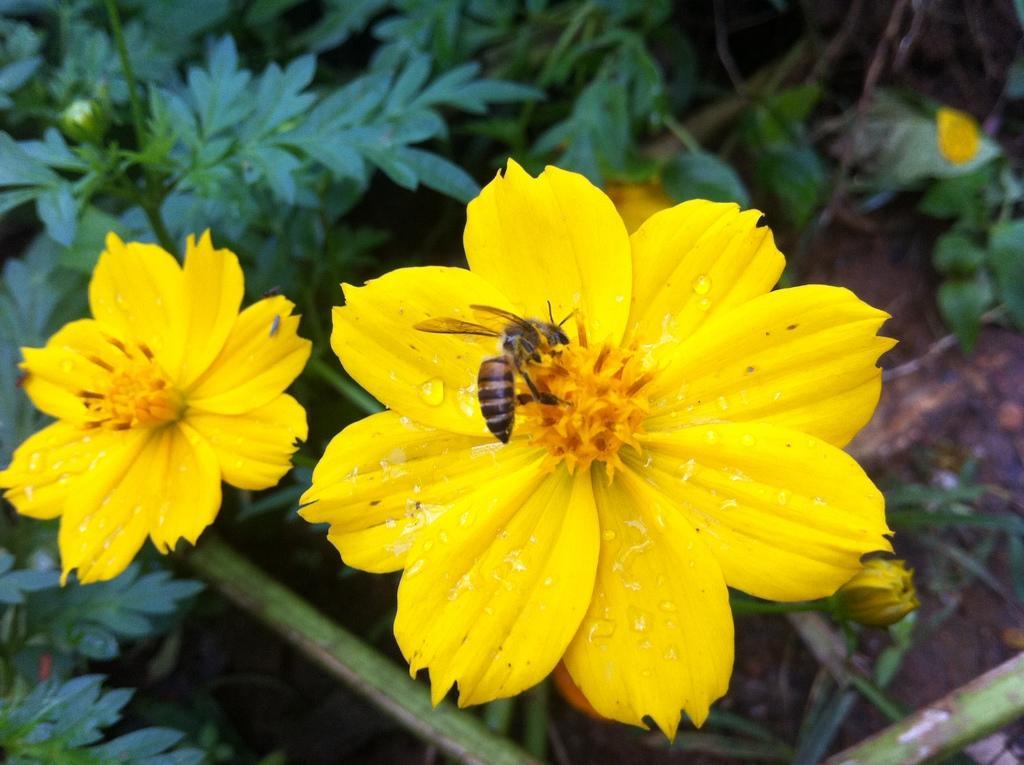Please provide a concise description of this image. In this picture I can observe yellow color flowers and a honey bee on one of the flowers. In the background there are some plants on the ground. 